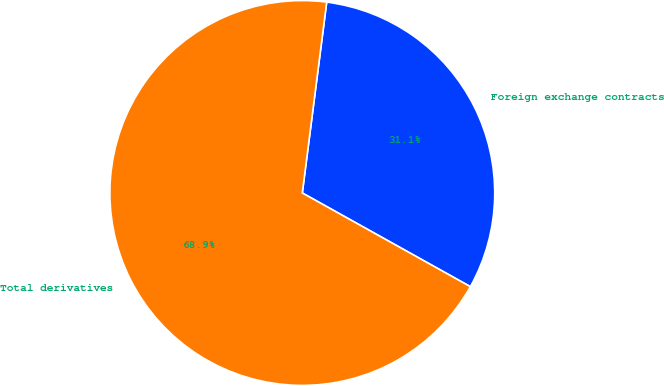Convert chart to OTSL. <chart><loc_0><loc_0><loc_500><loc_500><pie_chart><fcel>Foreign exchange contracts<fcel>Total derivatives<nl><fcel>31.07%<fcel>68.93%<nl></chart> 